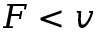<formula> <loc_0><loc_0><loc_500><loc_500>F < v</formula> 